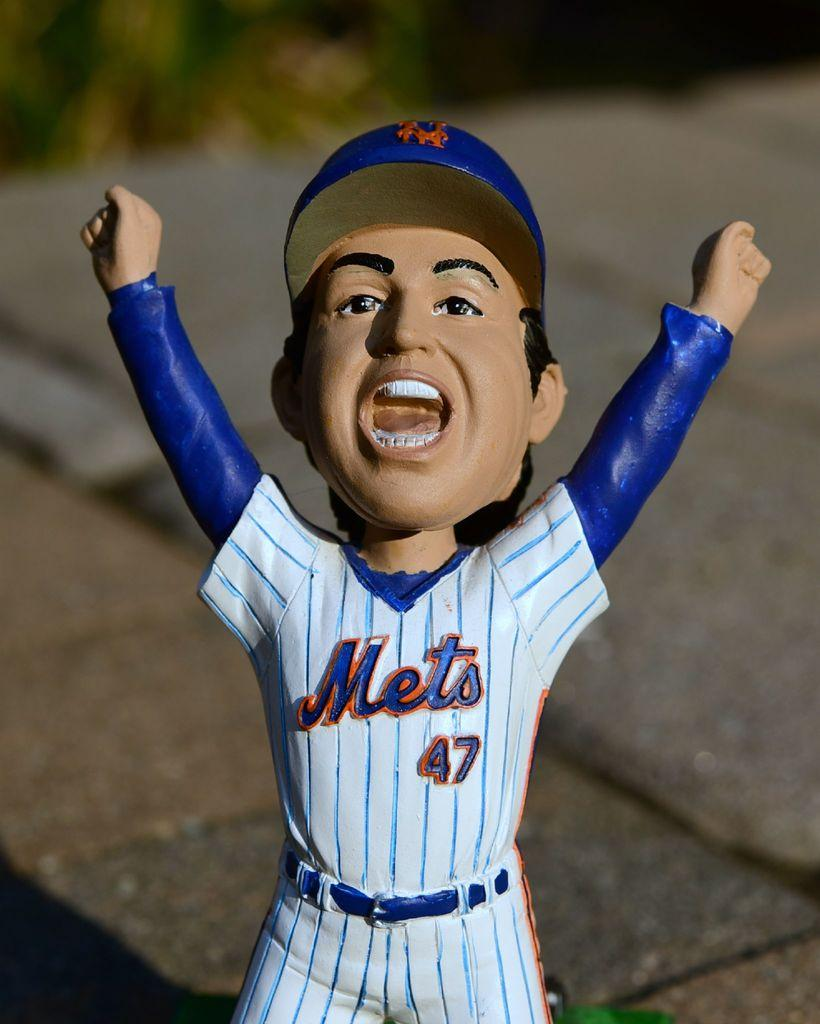<image>
Relay a brief, clear account of the picture shown. A number 47 Mets Bobble Head is sitting on the stone ground outside. 